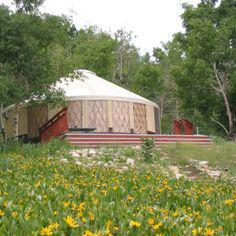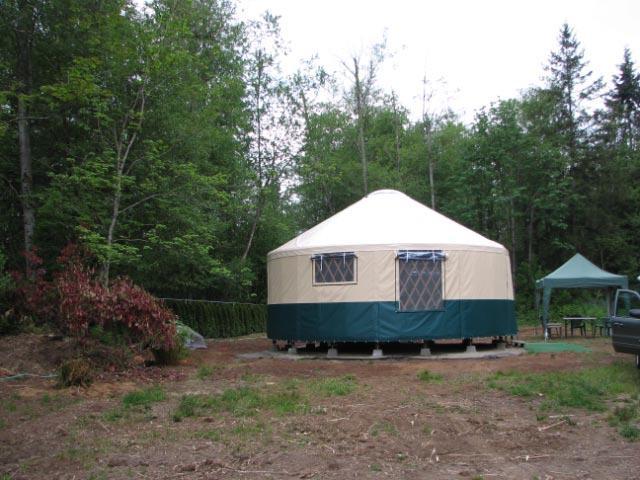The first image is the image on the left, the second image is the image on the right. For the images shown, is this caption "Left image shows a domed structure with darker top and bottom sections and a wooden railed walkway curving around it." true? Answer yes or no. No. The first image is the image on the left, the second image is the image on the right. Evaluate the accuracy of this statement regarding the images: "There is a wooden rail around the hut in the image on the right.". Is it true? Answer yes or no. No. 